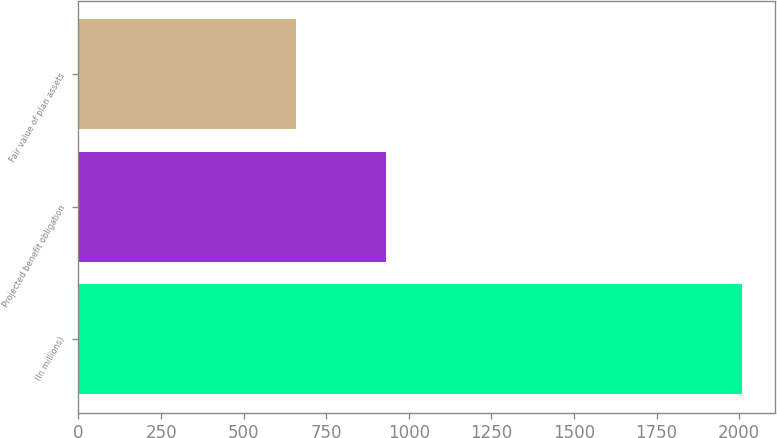Convert chart. <chart><loc_0><loc_0><loc_500><loc_500><bar_chart><fcel>(In millions)<fcel>Projected benefit obligation<fcel>Fair value of plan assets<nl><fcel>2008<fcel>930.2<fcel>657.3<nl></chart> 